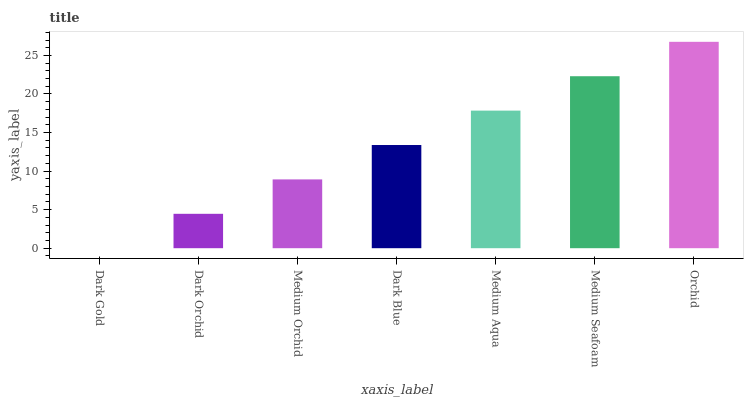Is Dark Gold the minimum?
Answer yes or no. Yes. Is Orchid the maximum?
Answer yes or no. Yes. Is Dark Orchid the minimum?
Answer yes or no. No. Is Dark Orchid the maximum?
Answer yes or no. No. Is Dark Orchid greater than Dark Gold?
Answer yes or no. Yes. Is Dark Gold less than Dark Orchid?
Answer yes or no. Yes. Is Dark Gold greater than Dark Orchid?
Answer yes or no. No. Is Dark Orchid less than Dark Gold?
Answer yes or no. No. Is Dark Blue the high median?
Answer yes or no. Yes. Is Dark Blue the low median?
Answer yes or no. Yes. Is Medium Seafoam the high median?
Answer yes or no. No. Is Dark Gold the low median?
Answer yes or no. No. 